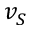Convert formula to latex. <formula><loc_0><loc_0><loc_500><loc_500>v _ { S }</formula> 